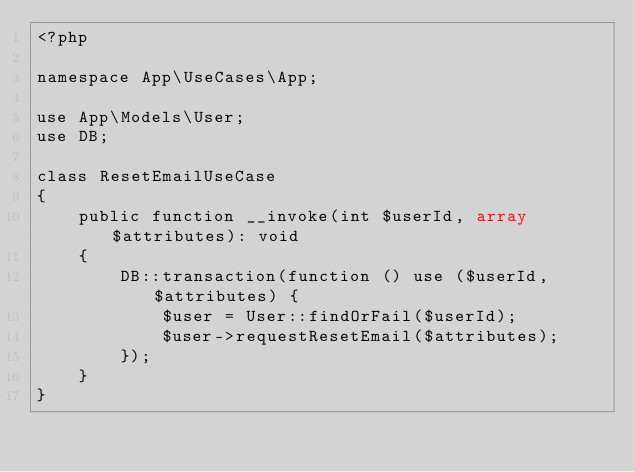<code> <loc_0><loc_0><loc_500><loc_500><_PHP_><?php

namespace App\UseCases\App;

use App\Models\User;
use DB;

class ResetEmailUseCase
{
    public function __invoke(int $userId, array $attributes): void
    {
        DB::transaction(function () use ($userId, $attributes) {
            $user = User::findOrFail($userId);
            $user->requestResetEmail($attributes);
        });
    }
}
</code> 